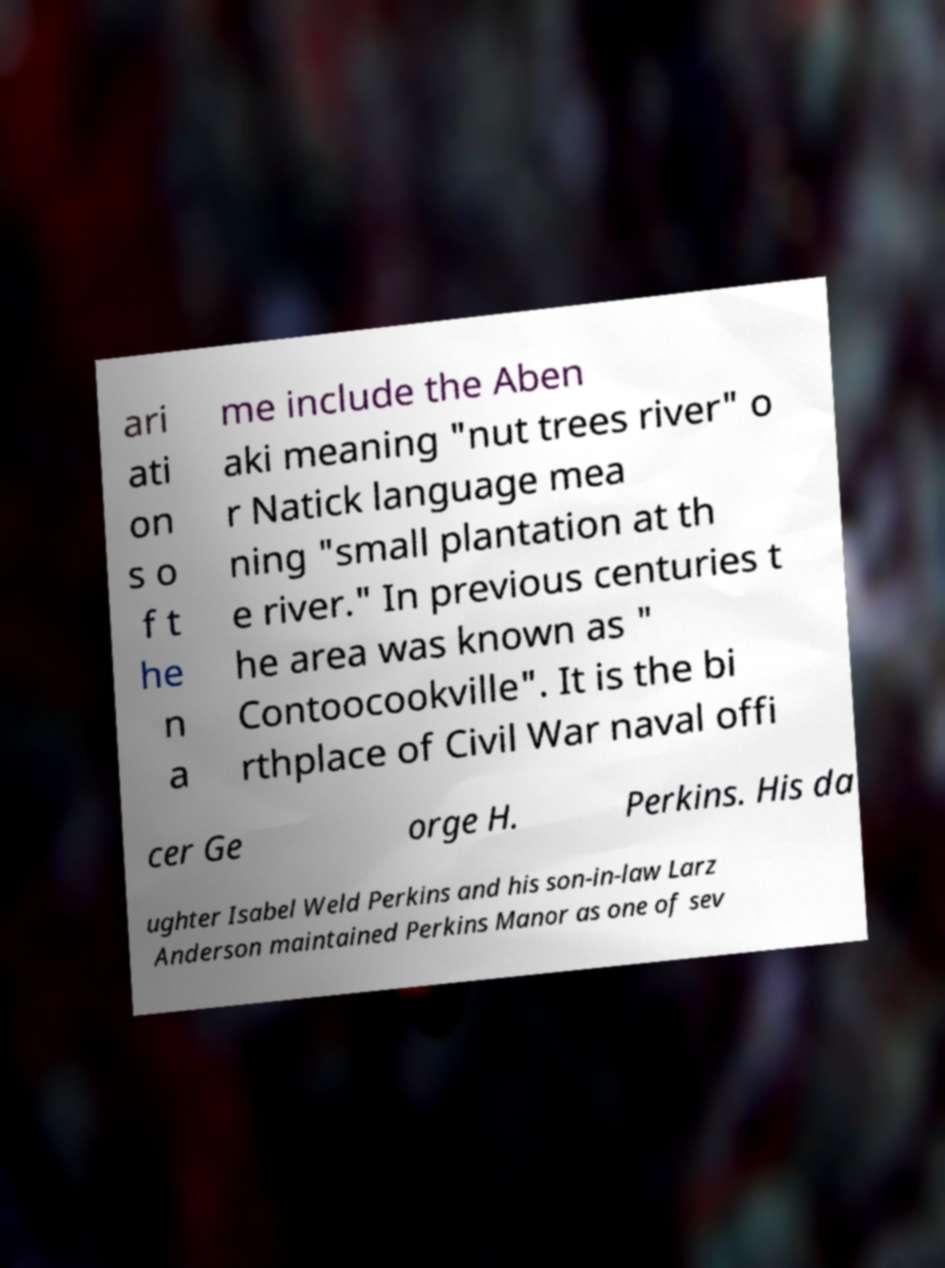Can you read and provide the text displayed in the image?This photo seems to have some interesting text. Can you extract and type it out for me? ari ati on s o f t he n a me include the Aben aki meaning "nut trees river" o r Natick language mea ning "small plantation at th e river." In previous centuries t he area was known as " Contoocookville". It is the bi rthplace of Civil War naval offi cer Ge orge H. Perkins. His da ughter Isabel Weld Perkins and his son-in-law Larz Anderson maintained Perkins Manor as one of sev 